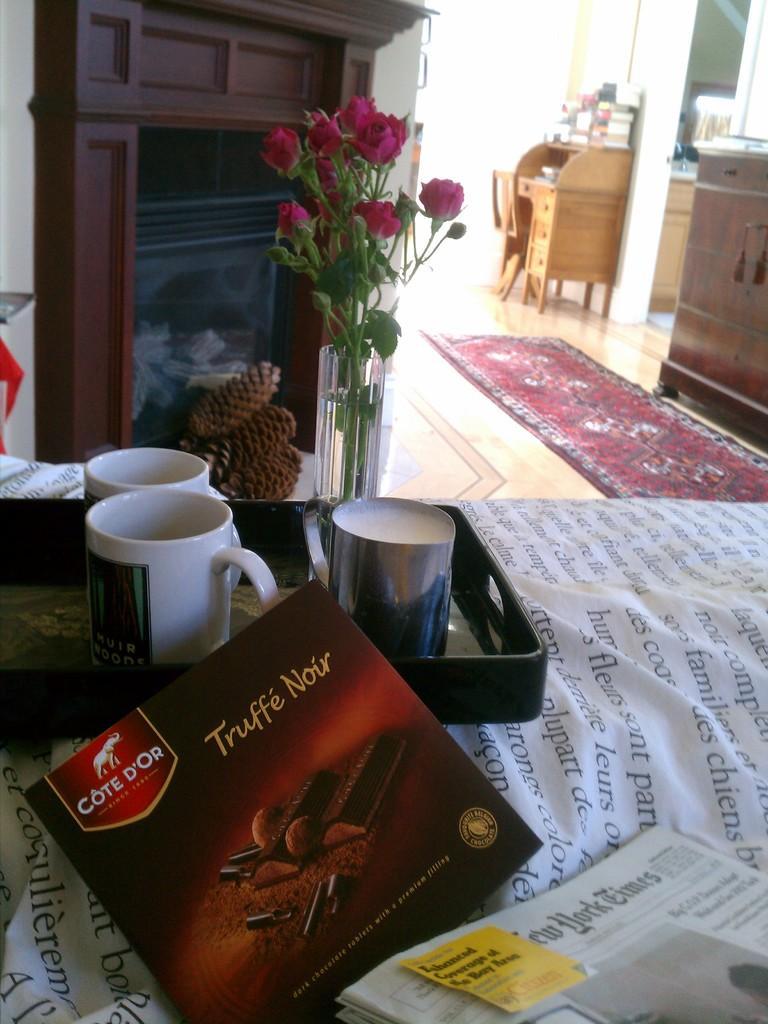Please provide a concise description of this image. In the center of the image we can see one table. On the table, we can see one cloth, one plate, newspapers, banners and mugs. On the cloth, we can see some text. In the background there is a wall, one wooden object, vase, flowers, tables, plants and a few other objects. 